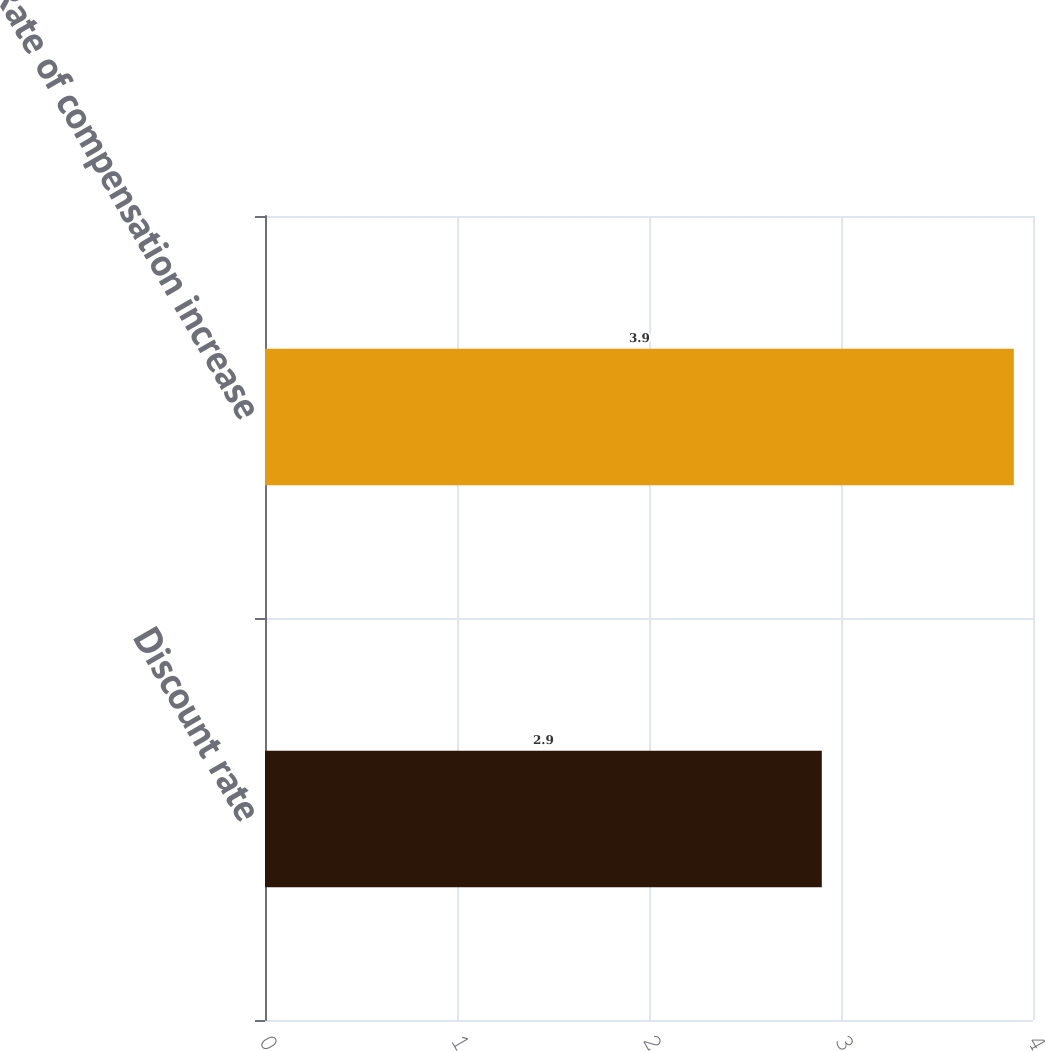<chart> <loc_0><loc_0><loc_500><loc_500><bar_chart><fcel>Discount rate<fcel>Rate of compensation increase<nl><fcel>2.9<fcel>3.9<nl></chart> 